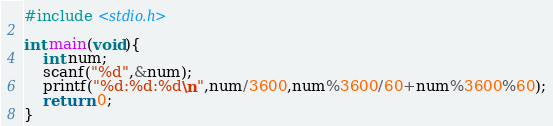Convert code to text. <code><loc_0><loc_0><loc_500><loc_500><_C_>#include <stdio.h>
  
int main(void){
    int num;
    scanf("%d",&num);
    printf("%d:%d:%d\n",num/3600,num%3600/60+num%3600%60);
    return 0;
}</code> 